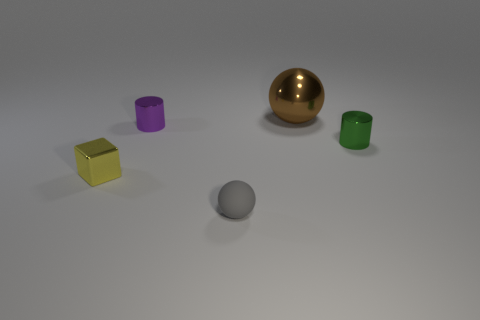Subtract all brown balls. How many balls are left? 1 Add 3 brown things. How many objects exist? 8 Subtract all cubes. How many objects are left? 4 Subtract 0 red balls. How many objects are left? 5 Subtract all cyan cylinders. Subtract all purple blocks. How many cylinders are left? 2 Subtract all green metal objects. Subtract all small green metallic objects. How many objects are left? 3 Add 1 green metal cylinders. How many green metal cylinders are left? 2 Add 1 tiny cyan shiny objects. How many tiny cyan shiny objects exist? 1 